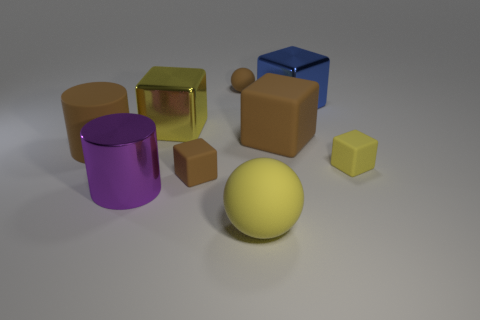Subtract all large metal cubes. How many cubes are left? 3 Subtract all green spheres. How many yellow blocks are left? 2 Subtract 1 cubes. How many cubes are left? 4 Subtract all yellow cubes. How many cubes are left? 3 Subtract all red cubes. Subtract all green cylinders. How many cubes are left? 5 Subtract all balls. How many objects are left? 7 Subtract all yellow rubber cubes. Subtract all small brown cubes. How many objects are left? 7 Add 8 yellow balls. How many yellow balls are left? 9 Add 3 yellow blocks. How many yellow blocks exist? 5 Subtract 0 red cylinders. How many objects are left? 9 